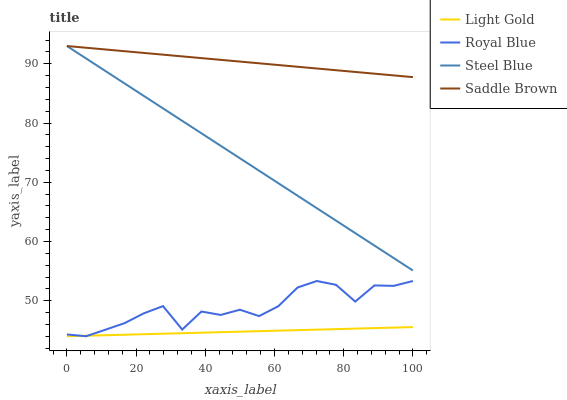Does Light Gold have the minimum area under the curve?
Answer yes or no. Yes. Does Saddle Brown have the maximum area under the curve?
Answer yes or no. Yes. Does Steel Blue have the minimum area under the curve?
Answer yes or no. No. Does Steel Blue have the maximum area under the curve?
Answer yes or no. No. Is Saddle Brown the smoothest?
Answer yes or no. Yes. Is Royal Blue the roughest?
Answer yes or no. Yes. Is Light Gold the smoothest?
Answer yes or no. No. Is Light Gold the roughest?
Answer yes or no. No. Does Royal Blue have the lowest value?
Answer yes or no. Yes. Does Steel Blue have the lowest value?
Answer yes or no. No. Does Saddle Brown have the highest value?
Answer yes or no. Yes. Does Light Gold have the highest value?
Answer yes or no. No. Is Royal Blue less than Steel Blue?
Answer yes or no. Yes. Is Steel Blue greater than Royal Blue?
Answer yes or no. Yes. Does Royal Blue intersect Light Gold?
Answer yes or no. Yes. Is Royal Blue less than Light Gold?
Answer yes or no. No. Is Royal Blue greater than Light Gold?
Answer yes or no. No. Does Royal Blue intersect Steel Blue?
Answer yes or no. No. 